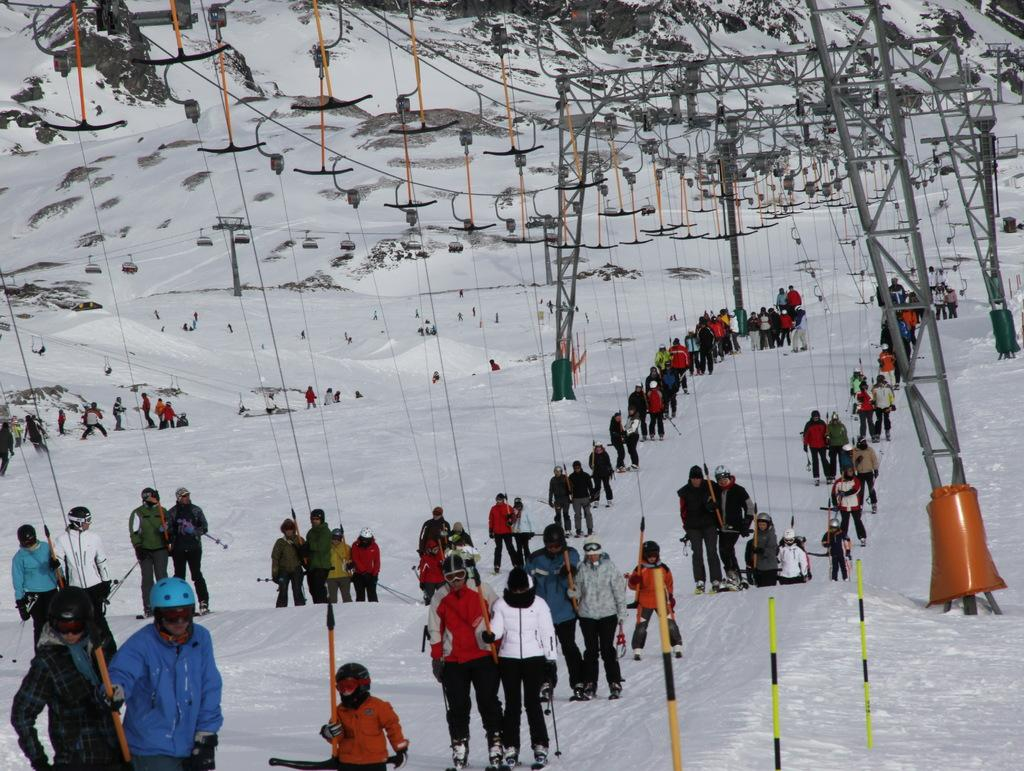What activity are the people in the image engaged in? The people in the image are skiing. What type of terrain are they skiing on? They are skiing in the snow. What can be seen in the top side of the image? There are cables visible in the top side of the image. Where can the honey be found in the image? There is no honey present in the image. What type of furniture is the person sitting on while skiing? The image does not show a person sitting on any furniture while skiing. 